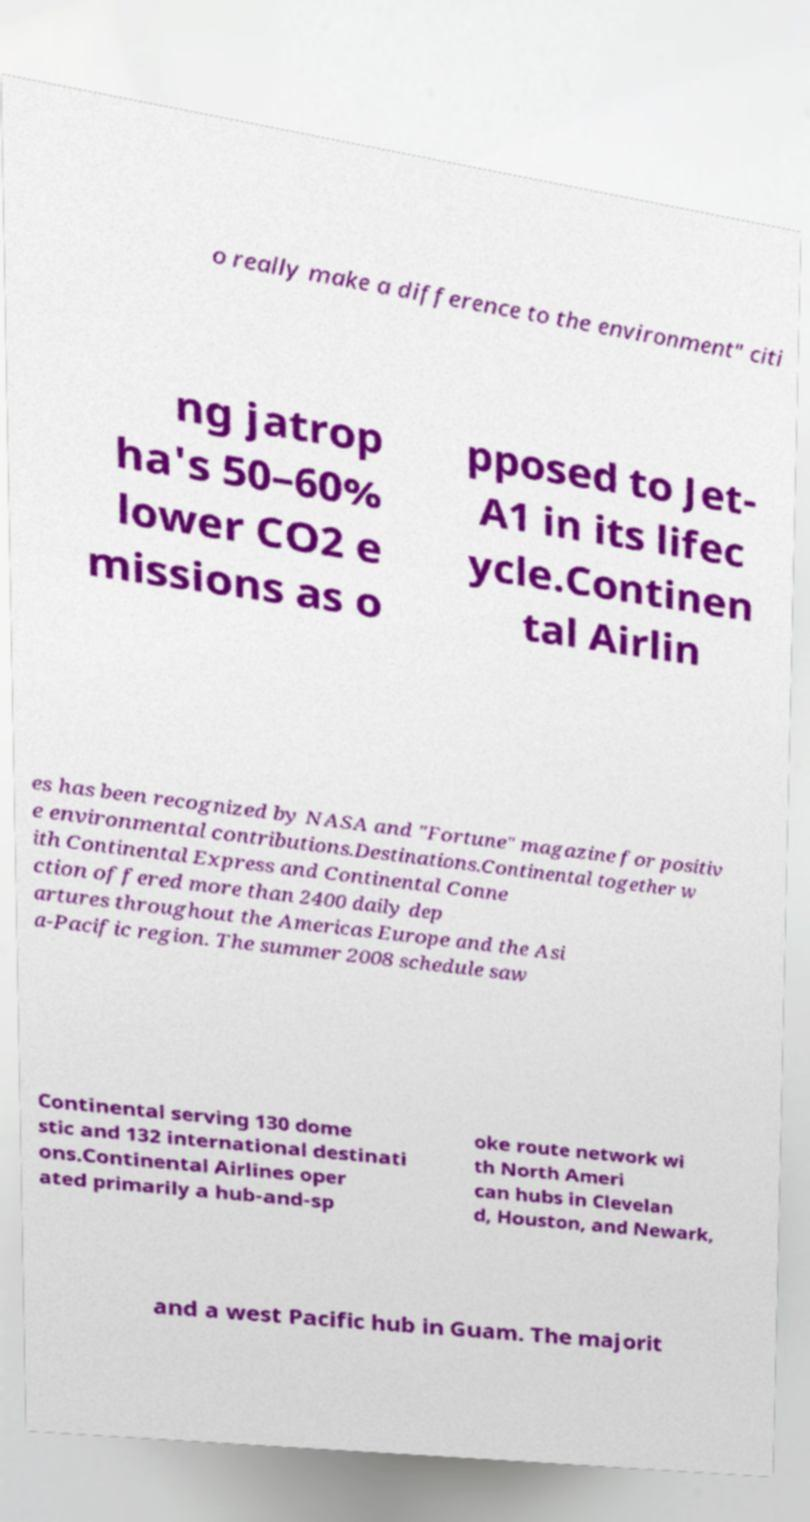Could you assist in decoding the text presented in this image and type it out clearly? o really make a difference to the environment" citi ng jatrop ha's 50–60% lower CO2 e missions as o pposed to Jet- A1 in its lifec ycle.Continen tal Airlin es has been recognized by NASA and "Fortune" magazine for positiv e environmental contributions.Destinations.Continental together w ith Continental Express and Continental Conne ction offered more than 2400 daily dep artures throughout the Americas Europe and the Asi a-Pacific region. The summer 2008 schedule saw Continental serving 130 dome stic and 132 international destinati ons.Continental Airlines oper ated primarily a hub-and-sp oke route network wi th North Ameri can hubs in Clevelan d, Houston, and Newark, and a west Pacific hub in Guam. The majorit 